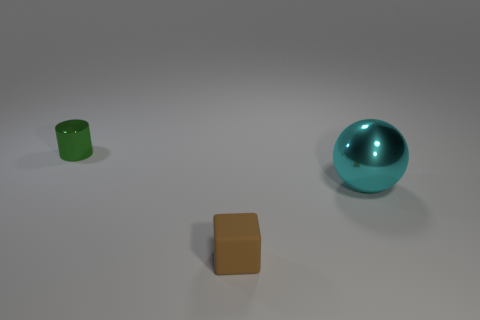What is the color theme of the objects presented? The color theme consists of a muted palette with a teal blue sphere, a matte olive green cylinder, and a brown cube. The colors are rather subdued and earthy. 